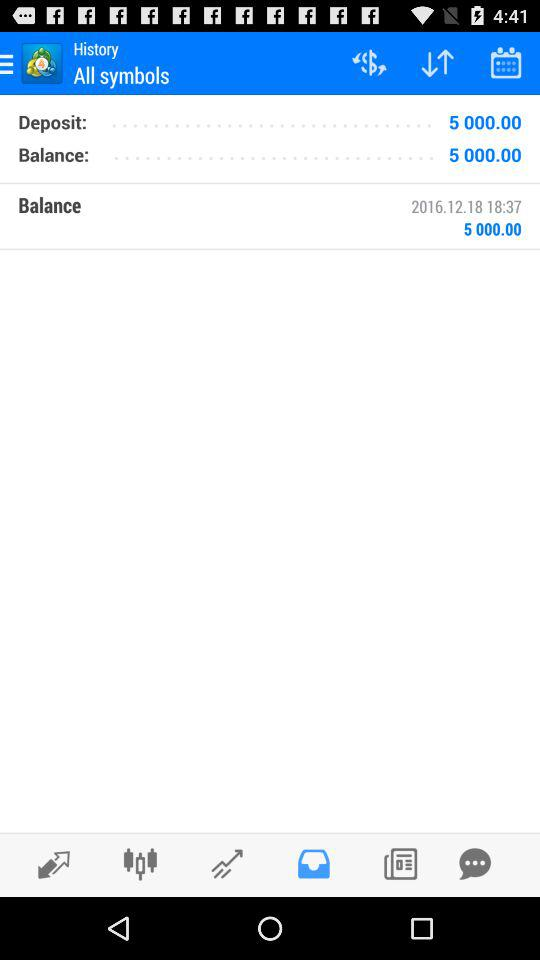How much is the deposit value? The deposit value is "5 000.00". 